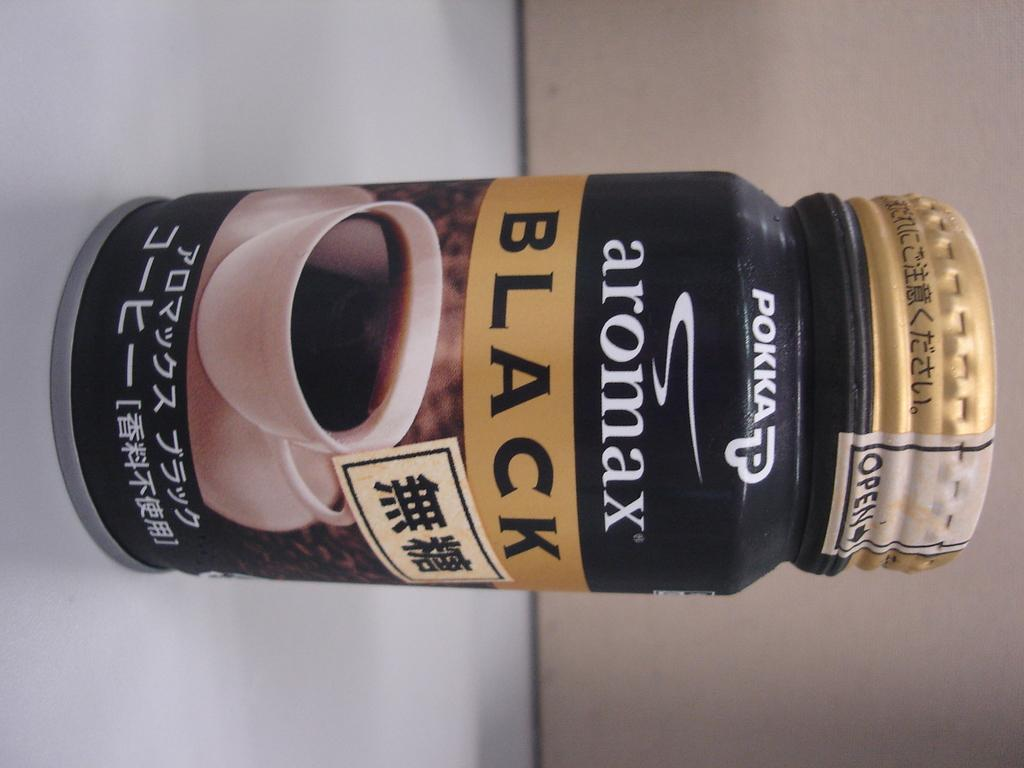<image>
Create a compact narrative representing the image presented. A closed and sealed container of Aromax black coffee. 